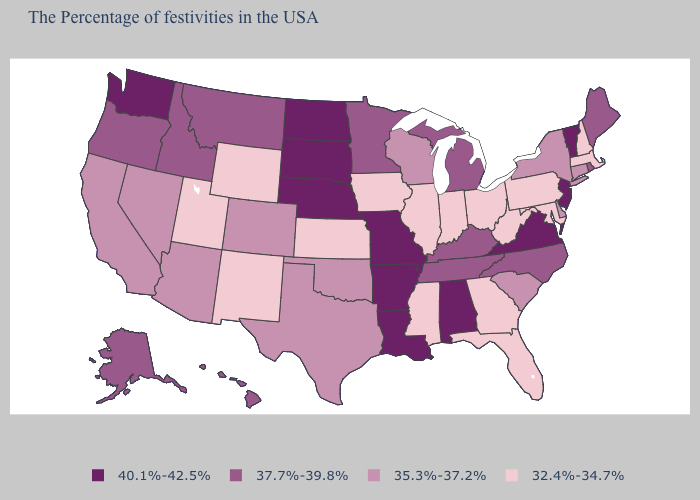Does Maine have the lowest value in the USA?
Write a very short answer. No. Does Alabama have the highest value in the USA?
Concise answer only. Yes. What is the value of California?
Keep it brief. 35.3%-37.2%. What is the highest value in states that border Massachusetts?
Write a very short answer. 40.1%-42.5%. Does Washington have the highest value in the West?
Quick response, please. Yes. Is the legend a continuous bar?
Concise answer only. No. What is the value of Arkansas?
Write a very short answer. 40.1%-42.5%. What is the value of South Dakota?
Be succinct. 40.1%-42.5%. What is the lowest value in the MidWest?
Be succinct. 32.4%-34.7%. What is the value of Arkansas?
Answer briefly. 40.1%-42.5%. What is the value of Maine?
Be succinct. 37.7%-39.8%. What is the value of Missouri?
Give a very brief answer. 40.1%-42.5%. Name the states that have a value in the range 35.3%-37.2%?
Give a very brief answer. Connecticut, New York, Delaware, South Carolina, Wisconsin, Oklahoma, Texas, Colorado, Arizona, Nevada, California. Does Minnesota have the lowest value in the MidWest?
Give a very brief answer. No. Does Mississippi have the lowest value in the USA?
Concise answer only. Yes. 